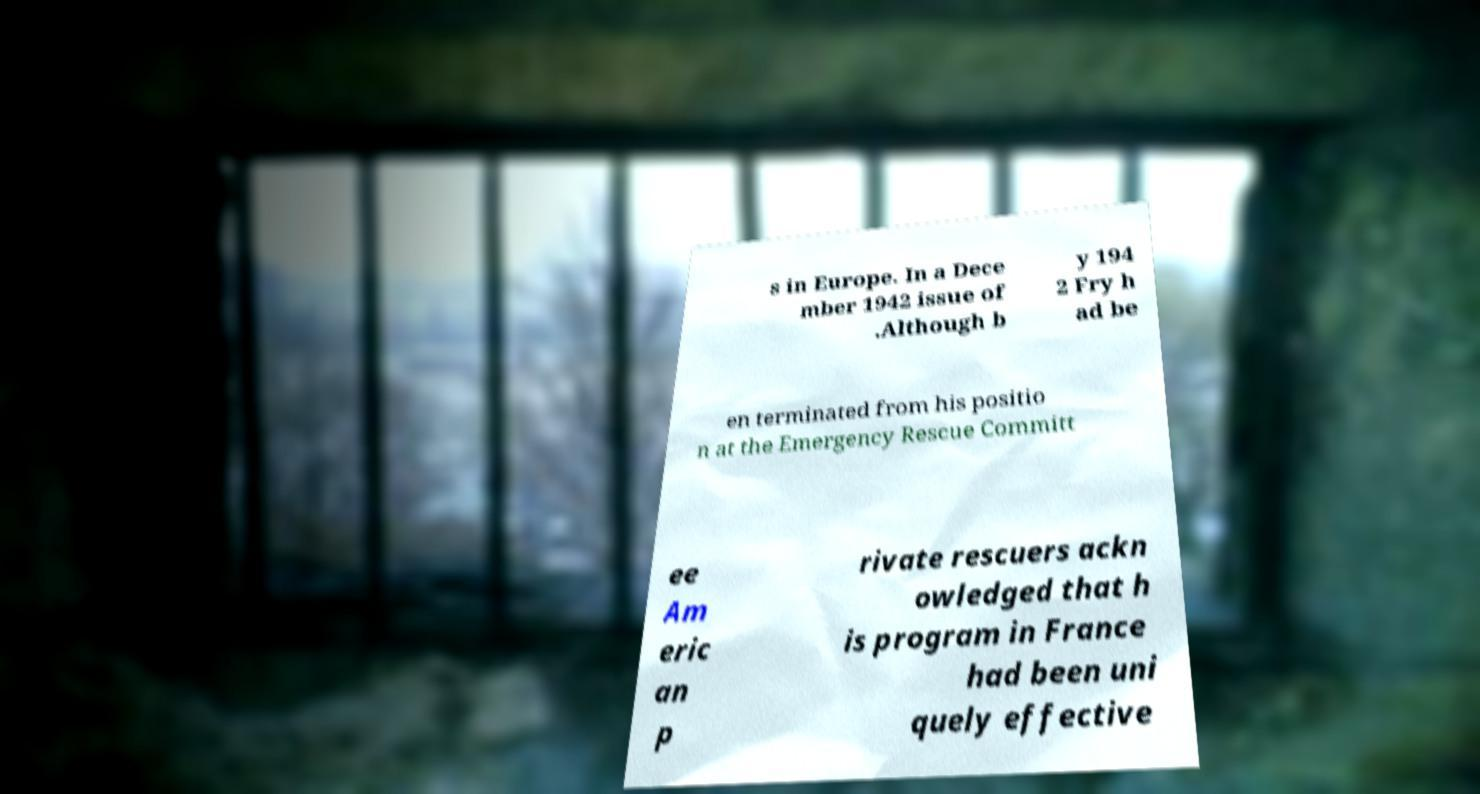What messages or text are displayed in this image? I need them in a readable, typed format. s in Europe. In a Dece mber 1942 issue of .Although b y 194 2 Fry h ad be en terminated from his positio n at the Emergency Rescue Committ ee Am eric an p rivate rescuers ackn owledged that h is program in France had been uni quely effective 